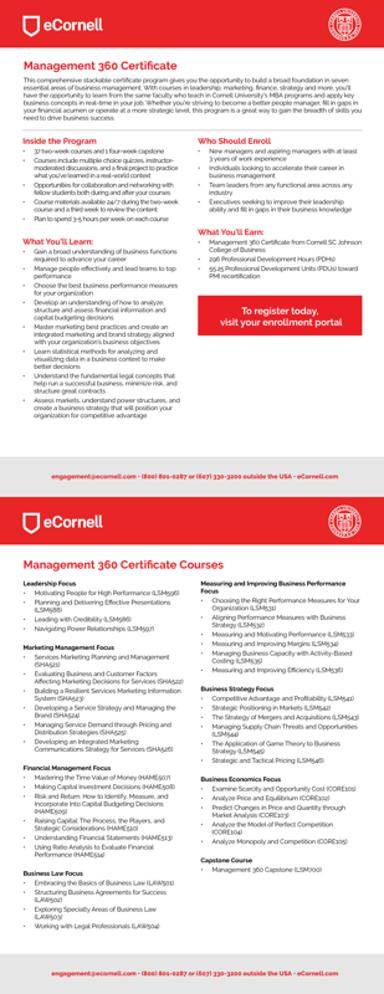What should someone do if they want to register for these courses? To register for the eCornell Management 360 Certificate courses, one should visit the enrollment portal as indicated in the image. For additional assistance or inquiries, the mentioned contact numbers are 800-804-0871 or 607-1330-3200. Prospective students can also email for support or further information. 